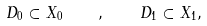<formula> <loc_0><loc_0><loc_500><loc_500>D _ { 0 } \subset X _ { 0 } \quad , \quad D _ { 1 } \subset X _ { 1 } ,</formula> 